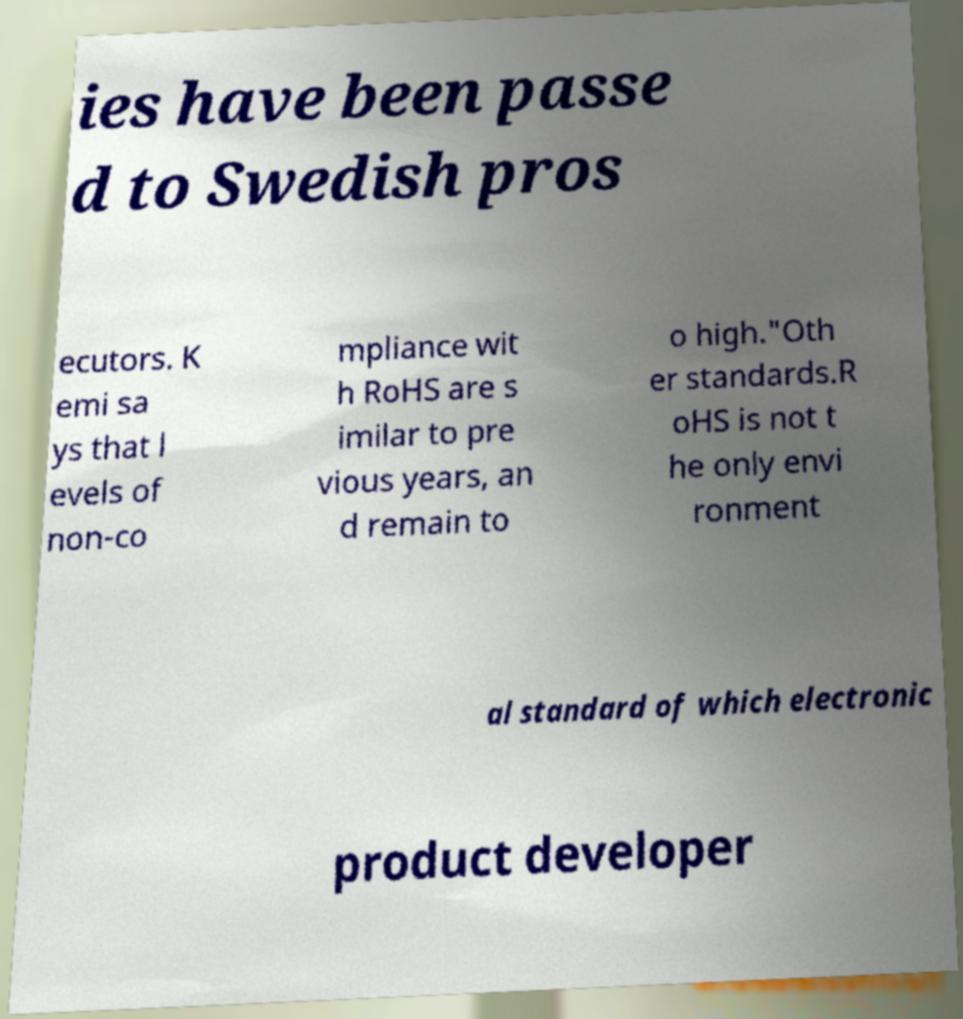Could you assist in decoding the text presented in this image and type it out clearly? ies have been passe d to Swedish pros ecutors. K emi sa ys that l evels of non-co mpliance wit h RoHS are s imilar to pre vious years, an d remain to o high."Oth er standards.R oHS is not t he only envi ronment al standard of which electronic product developer 